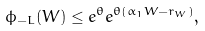<formula> <loc_0><loc_0><loc_500><loc_500>\phi _ { - L } ( W ) \leq e ^ { \theta } e ^ { \theta ( \alpha _ { 1 } W - r _ { W } ) } ,</formula> 